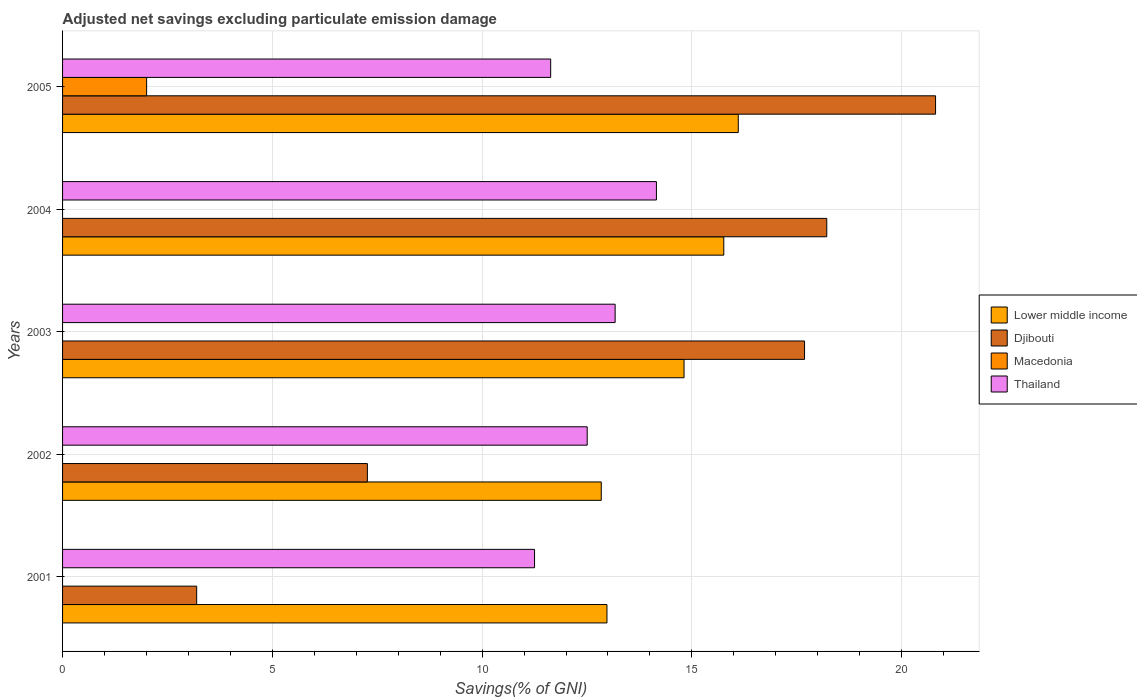How many groups of bars are there?
Keep it short and to the point. 5. Are the number of bars per tick equal to the number of legend labels?
Give a very brief answer. No. Are the number of bars on each tick of the Y-axis equal?
Your answer should be very brief. No. How many bars are there on the 5th tick from the top?
Offer a terse response. 3. How many bars are there on the 4th tick from the bottom?
Keep it short and to the point. 3. What is the adjusted net savings in Macedonia in 2003?
Your answer should be compact. 0. Across all years, what is the maximum adjusted net savings in Thailand?
Make the answer very short. 14.16. Across all years, what is the minimum adjusted net savings in Djibouti?
Provide a short and direct response. 3.2. What is the total adjusted net savings in Thailand in the graph?
Your answer should be very brief. 62.72. What is the difference between the adjusted net savings in Thailand in 2004 and that in 2005?
Offer a terse response. 2.52. What is the difference between the adjusted net savings in Lower middle income in 2005 and the adjusted net savings in Thailand in 2002?
Keep it short and to the point. 3.6. What is the average adjusted net savings in Thailand per year?
Offer a terse response. 12.54. In the year 2002, what is the difference between the adjusted net savings in Thailand and adjusted net savings in Lower middle income?
Your answer should be very brief. -0.33. In how many years, is the adjusted net savings in Djibouti greater than 1 %?
Your response must be concise. 5. What is the ratio of the adjusted net savings in Thailand in 2001 to that in 2004?
Give a very brief answer. 0.79. What is the difference between the highest and the second highest adjusted net savings in Djibouti?
Offer a very short reply. 2.59. What is the difference between the highest and the lowest adjusted net savings in Macedonia?
Your answer should be compact. 2. In how many years, is the adjusted net savings in Thailand greater than the average adjusted net savings in Thailand taken over all years?
Ensure brevity in your answer.  2. Is it the case that in every year, the sum of the adjusted net savings in Macedonia and adjusted net savings in Djibouti is greater than the adjusted net savings in Lower middle income?
Ensure brevity in your answer.  No. How many bars are there?
Provide a succinct answer. 16. How many years are there in the graph?
Give a very brief answer. 5. What is the difference between two consecutive major ticks on the X-axis?
Offer a very short reply. 5. Does the graph contain grids?
Your answer should be very brief. Yes. Where does the legend appear in the graph?
Offer a very short reply. Center right. What is the title of the graph?
Your response must be concise. Adjusted net savings excluding particulate emission damage. Does "China" appear as one of the legend labels in the graph?
Provide a short and direct response. No. What is the label or title of the X-axis?
Your answer should be very brief. Savings(% of GNI). What is the Savings(% of GNI) in Lower middle income in 2001?
Your answer should be very brief. 12.98. What is the Savings(% of GNI) of Djibouti in 2001?
Ensure brevity in your answer.  3.2. What is the Savings(% of GNI) of Thailand in 2001?
Make the answer very short. 11.25. What is the Savings(% of GNI) of Lower middle income in 2002?
Provide a short and direct response. 12.84. What is the Savings(% of GNI) in Djibouti in 2002?
Your answer should be compact. 7.27. What is the Savings(% of GNI) of Macedonia in 2002?
Offer a terse response. 0. What is the Savings(% of GNI) of Thailand in 2002?
Your answer should be compact. 12.51. What is the Savings(% of GNI) in Lower middle income in 2003?
Keep it short and to the point. 14.81. What is the Savings(% of GNI) of Djibouti in 2003?
Offer a very short reply. 17.69. What is the Savings(% of GNI) of Macedonia in 2003?
Your answer should be compact. 0. What is the Savings(% of GNI) of Thailand in 2003?
Provide a succinct answer. 13.17. What is the Savings(% of GNI) in Lower middle income in 2004?
Provide a succinct answer. 15.76. What is the Savings(% of GNI) in Djibouti in 2004?
Your response must be concise. 18.22. What is the Savings(% of GNI) of Thailand in 2004?
Offer a very short reply. 14.16. What is the Savings(% of GNI) of Lower middle income in 2005?
Give a very brief answer. 16.11. What is the Savings(% of GNI) in Djibouti in 2005?
Your answer should be compact. 20.81. What is the Savings(% of GNI) in Macedonia in 2005?
Provide a short and direct response. 2. What is the Savings(% of GNI) of Thailand in 2005?
Make the answer very short. 11.63. Across all years, what is the maximum Savings(% of GNI) of Lower middle income?
Make the answer very short. 16.11. Across all years, what is the maximum Savings(% of GNI) of Djibouti?
Your answer should be very brief. 20.81. Across all years, what is the maximum Savings(% of GNI) in Macedonia?
Give a very brief answer. 2. Across all years, what is the maximum Savings(% of GNI) of Thailand?
Your answer should be compact. 14.16. Across all years, what is the minimum Savings(% of GNI) of Lower middle income?
Your answer should be very brief. 12.84. Across all years, what is the minimum Savings(% of GNI) in Djibouti?
Provide a succinct answer. 3.2. Across all years, what is the minimum Savings(% of GNI) in Thailand?
Ensure brevity in your answer.  11.25. What is the total Savings(% of GNI) in Lower middle income in the graph?
Give a very brief answer. 72.5. What is the total Savings(% of GNI) in Djibouti in the graph?
Your answer should be compact. 67.17. What is the total Savings(% of GNI) of Macedonia in the graph?
Offer a terse response. 2. What is the total Savings(% of GNI) in Thailand in the graph?
Provide a short and direct response. 62.72. What is the difference between the Savings(% of GNI) in Lower middle income in 2001 and that in 2002?
Provide a succinct answer. 0.14. What is the difference between the Savings(% of GNI) of Djibouti in 2001 and that in 2002?
Keep it short and to the point. -4.07. What is the difference between the Savings(% of GNI) of Thailand in 2001 and that in 2002?
Ensure brevity in your answer.  -1.26. What is the difference between the Savings(% of GNI) in Lower middle income in 2001 and that in 2003?
Make the answer very short. -1.84. What is the difference between the Savings(% of GNI) of Djibouti in 2001 and that in 2003?
Make the answer very short. -14.49. What is the difference between the Savings(% of GNI) of Thailand in 2001 and that in 2003?
Provide a short and direct response. -1.92. What is the difference between the Savings(% of GNI) in Lower middle income in 2001 and that in 2004?
Provide a succinct answer. -2.78. What is the difference between the Savings(% of GNI) in Djibouti in 2001 and that in 2004?
Provide a succinct answer. -15.02. What is the difference between the Savings(% of GNI) in Thailand in 2001 and that in 2004?
Provide a succinct answer. -2.9. What is the difference between the Savings(% of GNI) of Lower middle income in 2001 and that in 2005?
Your response must be concise. -3.13. What is the difference between the Savings(% of GNI) in Djibouti in 2001 and that in 2005?
Ensure brevity in your answer.  -17.61. What is the difference between the Savings(% of GNI) in Thailand in 2001 and that in 2005?
Ensure brevity in your answer.  -0.38. What is the difference between the Savings(% of GNI) of Lower middle income in 2002 and that in 2003?
Offer a terse response. -1.97. What is the difference between the Savings(% of GNI) of Djibouti in 2002 and that in 2003?
Provide a succinct answer. -10.42. What is the difference between the Savings(% of GNI) of Thailand in 2002 and that in 2003?
Offer a terse response. -0.67. What is the difference between the Savings(% of GNI) of Lower middle income in 2002 and that in 2004?
Offer a very short reply. -2.92. What is the difference between the Savings(% of GNI) of Djibouti in 2002 and that in 2004?
Make the answer very short. -10.95. What is the difference between the Savings(% of GNI) of Thailand in 2002 and that in 2004?
Your answer should be compact. -1.65. What is the difference between the Savings(% of GNI) in Lower middle income in 2002 and that in 2005?
Give a very brief answer. -3.27. What is the difference between the Savings(% of GNI) of Djibouti in 2002 and that in 2005?
Give a very brief answer. -13.54. What is the difference between the Savings(% of GNI) in Thailand in 2002 and that in 2005?
Your answer should be very brief. 0.87. What is the difference between the Savings(% of GNI) of Lower middle income in 2003 and that in 2004?
Your response must be concise. -0.95. What is the difference between the Savings(% of GNI) of Djibouti in 2003 and that in 2004?
Give a very brief answer. -0.53. What is the difference between the Savings(% of GNI) of Thailand in 2003 and that in 2004?
Offer a terse response. -0.98. What is the difference between the Savings(% of GNI) in Lower middle income in 2003 and that in 2005?
Make the answer very short. -1.29. What is the difference between the Savings(% of GNI) in Djibouti in 2003 and that in 2005?
Keep it short and to the point. -3.12. What is the difference between the Savings(% of GNI) in Thailand in 2003 and that in 2005?
Provide a short and direct response. 1.54. What is the difference between the Savings(% of GNI) in Lower middle income in 2004 and that in 2005?
Your answer should be very brief. -0.35. What is the difference between the Savings(% of GNI) in Djibouti in 2004 and that in 2005?
Give a very brief answer. -2.59. What is the difference between the Savings(% of GNI) of Thailand in 2004 and that in 2005?
Make the answer very short. 2.52. What is the difference between the Savings(% of GNI) of Lower middle income in 2001 and the Savings(% of GNI) of Djibouti in 2002?
Your answer should be compact. 5.71. What is the difference between the Savings(% of GNI) of Lower middle income in 2001 and the Savings(% of GNI) of Thailand in 2002?
Your answer should be very brief. 0.47. What is the difference between the Savings(% of GNI) in Djibouti in 2001 and the Savings(% of GNI) in Thailand in 2002?
Give a very brief answer. -9.31. What is the difference between the Savings(% of GNI) in Lower middle income in 2001 and the Savings(% of GNI) in Djibouti in 2003?
Your response must be concise. -4.71. What is the difference between the Savings(% of GNI) of Lower middle income in 2001 and the Savings(% of GNI) of Thailand in 2003?
Make the answer very short. -0.2. What is the difference between the Savings(% of GNI) in Djibouti in 2001 and the Savings(% of GNI) in Thailand in 2003?
Your answer should be compact. -9.97. What is the difference between the Savings(% of GNI) of Lower middle income in 2001 and the Savings(% of GNI) of Djibouti in 2004?
Keep it short and to the point. -5.24. What is the difference between the Savings(% of GNI) in Lower middle income in 2001 and the Savings(% of GNI) in Thailand in 2004?
Offer a terse response. -1.18. What is the difference between the Savings(% of GNI) of Djibouti in 2001 and the Savings(% of GNI) of Thailand in 2004?
Make the answer very short. -10.96. What is the difference between the Savings(% of GNI) in Lower middle income in 2001 and the Savings(% of GNI) in Djibouti in 2005?
Give a very brief answer. -7.83. What is the difference between the Savings(% of GNI) of Lower middle income in 2001 and the Savings(% of GNI) of Macedonia in 2005?
Your answer should be very brief. 10.97. What is the difference between the Savings(% of GNI) of Lower middle income in 2001 and the Savings(% of GNI) of Thailand in 2005?
Make the answer very short. 1.34. What is the difference between the Savings(% of GNI) in Djibouti in 2001 and the Savings(% of GNI) in Macedonia in 2005?
Your answer should be compact. 1.19. What is the difference between the Savings(% of GNI) in Djibouti in 2001 and the Savings(% of GNI) in Thailand in 2005?
Keep it short and to the point. -8.44. What is the difference between the Savings(% of GNI) in Lower middle income in 2002 and the Savings(% of GNI) in Djibouti in 2003?
Your response must be concise. -4.85. What is the difference between the Savings(% of GNI) of Lower middle income in 2002 and the Savings(% of GNI) of Thailand in 2003?
Give a very brief answer. -0.33. What is the difference between the Savings(% of GNI) in Djibouti in 2002 and the Savings(% of GNI) in Thailand in 2003?
Ensure brevity in your answer.  -5.91. What is the difference between the Savings(% of GNI) in Lower middle income in 2002 and the Savings(% of GNI) in Djibouti in 2004?
Your response must be concise. -5.38. What is the difference between the Savings(% of GNI) in Lower middle income in 2002 and the Savings(% of GNI) in Thailand in 2004?
Keep it short and to the point. -1.31. What is the difference between the Savings(% of GNI) in Djibouti in 2002 and the Savings(% of GNI) in Thailand in 2004?
Your answer should be very brief. -6.89. What is the difference between the Savings(% of GNI) of Lower middle income in 2002 and the Savings(% of GNI) of Djibouti in 2005?
Give a very brief answer. -7.97. What is the difference between the Savings(% of GNI) in Lower middle income in 2002 and the Savings(% of GNI) in Macedonia in 2005?
Ensure brevity in your answer.  10.84. What is the difference between the Savings(% of GNI) of Lower middle income in 2002 and the Savings(% of GNI) of Thailand in 2005?
Your answer should be very brief. 1.21. What is the difference between the Savings(% of GNI) of Djibouti in 2002 and the Savings(% of GNI) of Macedonia in 2005?
Give a very brief answer. 5.26. What is the difference between the Savings(% of GNI) in Djibouti in 2002 and the Savings(% of GNI) in Thailand in 2005?
Offer a terse response. -4.37. What is the difference between the Savings(% of GNI) of Lower middle income in 2003 and the Savings(% of GNI) of Djibouti in 2004?
Your answer should be very brief. -3.4. What is the difference between the Savings(% of GNI) of Lower middle income in 2003 and the Savings(% of GNI) of Thailand in 2004?
Your answer should be very brief. 0.66. What is the difference between the Savings(% of GNI) of Djibouti in 2003 and the Savings(% of GNI) of Thailand in 2004?
Provide a succinct answer. 3.53. What is the difference between the Savings(% of GNI) of Lower middle income in 2003 and the Savings(% of GNI) of Djibouti in 2005?
Ensure brevity in your answer.  -6. What is the difference between the Savings(% of GNI) in Lower middle income in 2003 and the Savings(% of GNI) in Macedonia in 2005?
Offer a very short reply. 12.81. What is the difference between the Savings(% of GNI) of Lower middle income in 2003 and the Savings(% of GNI) of Thailand in 2005?
Your answer should be compact. 3.18. What is the difference between the Savings(% of GNI) in Djibouti in 2003 and the Savings(% of GNI) in Macedonia in 2005?
Ensure brevity in your answer.  15.68. What is the difference between the Savings(% of GNI) of Djibouti in 2003 and the Savings(% of GNI) of Thailand in 2005?
Your answer should be very brief. 6.05. What is the difference between the Savings(% of GNI) in Lower middle income in 2004 and the Savings(% of GNI) in Djibouti in 2005?
Give a very brief answer. -5.05. What is the difference between the Savings(% of GNI) in Lower middle income in 2004 and the Savings(% of GNI) in Macedonia in 2005?
Give a very brief answer. 13.76. What is the difference between the Savings(% of GNI) in Lower middle income in 2004 and the Savings(% of GNI) in Thailand in 2005?
Give a very brief answer. 4.13. What is the difference between the Savings(% of GNI) in Djibouti in 2004 and the Savings(% of GNI) in Macedonia in 2005?
Your response must be concise. 16.21. What is the difference between the Savings(% of GNI) of Djibouti in 2004 and the Savings(% of GNI) of Thailand in 2005?
Provide a short and direct response. 6.58. What is the average Savings(% of GNI) of Lower middle income per year?
Offer a terse response. 14.5. What is the average Savings(% of GNI) of Djibouti per year?
Make the answer very short. 13.43. What is the average Savings(% of GNI) in Macedonia per year?
Make the answer very short. 0.4. What is the average Savings(% of GNI) in Thailand per year?
Ensure brevity in your answer.  12.54. In the year 2001, what is the difference between the Savings(% of GNI) of Lower middle income and Savings(% of GNI) of Djibouti?
Offer a terse response. 9.78. In the year 2001, what is the difference between the Savings(% of GNI) of Lower middle income and Savings(% of GNI) of Thailand?
Make the answer very short. 1.73. In the year 2001, what is the difference between the Savings(% of GNI) of Djibouti and Savings(% of GNI) of Thailand?
Provide a succinct answer. -8.05. In the year 2002, what is the difference between the Savings(% of GNI) of Lower middle income and Savings(% of GNI) of Djibouti?
Ensure brevity in your answer.  5.57. In the year 2002, what is the difference between the Savings(% of GNI) of Lower middle income and Savings(% of GNI) of Thailand?
Provide a succinct answer. 0.33. In the year 2002, what is the difference between the Savings(% of GNI) of Djibouti and Savings(% of GNI) of Thailand?
Offer a very short reply. -5.24. In the year 2003, what is the difference between the Savings(% of GNI) of Lower middle income and Savings(% of GNI) of Djibouti?
Give a very brief answer. -2.87. In the year 2003, what is the difference between the Savings(% of GNI) of Lower middle income and Savings(% of GNI) of Thailand?
Offer a very short reply. 1.64. In the year 2003, what is the difference between the Savings(% of GNI) of Djibouti and Savings(% of GNI) of Thailand?
Provide a succinct answer. 4.51. In the year 2004, what is the difference between the Savings(% of GNI) in Lower middle income and Savings(% of GNI) in Djibouti?
Provide a short and direct response. -2.45. In the year 2004, what is the difference between the Savings(% of GNI) of Lower middle income and Savings(% of GNI) of Thailand?
Your answer should be compact. 1.61. In the year 2004, what is the difference between the Savings(% of GNI) in Djibouti and Savings(% of GNI) in Thailand?
Your response must be concise. 4.06. In the year 2005, what is the difference between the Savings(% of GNI) of Lower middle income and Savings(% of GNI) of Djibouti?
Offer a terse response. -4.7. In the year 2005, what is the difference between the Savings(% of GNI) of Lower middle income and Savings(% of GNI) of Macedonia?
Provide a succinct answer. 14.1. In the year 2005, what is the difference between the Savings(% of GNI) in Lower middle income and Savings(% of GNI) in Thailand?
Give a very brief answer. 4.47. In the year 2005, what is the difference between the Savings(% of GNI) in Djibouti and Savings(% of GNI) in Macedonia?
Offer a terse response. 18.8. In the year 2005, what is the difference between the Savings(% of GNI) in Djibouti and Savings(% of GNI) in Thailand?
Keep it short and to the point. 9.17. In the year 2005, what is the difference between the Savings(% of GNI) in Macedonia and Savings(% of GNI) in Thailand?
Your response must be concise. -9.63. What is the ratio of the Savings(% of GNI) of Lower middle income in 2001 to that in 2002?
Your answer should be compact. 1.01. What is the ratio of the Savings(% of GNI) of Djibouti in 2001 to that in 2002?
Give a very brief answer. 0.44. What is the ratio of the Savings(% of GNI) in Thailand in 2001 to that in 2002?
Give a very brief answer. 0.9. What is the ratio of the Savings(% of GNI) of Lower middle income in 2001 to that in 2003?
Your answer should be compact. 0.88. What is the ratio of the Savings(% of GNI) of Djibouti in 2001 to that in 2003?
Ensure brevity in your answer.  0.18. What is the ratio of the Savings(% of GNI) of Thailand in 2001 to that in 2003?
Your answer should be compact. 0.85. What is the ratio of the Savings(% of GNI) of Lower middle income in 2001 to that in 2004?
Offer a very short reply. 0.82. What is the ratio of the Savings(% of GNI) of Djibouti in 2001 to that in 2004?
Provide a succinct answer. 0.18. What is the ratio of the Savings(% of GNI) of Thailand in 2001 to that in 2004?
Keep it short and to the point. 0.79. What is the ratio of the Savings(% of GNI) of Lower middle income in 2001 to that in 2005?
Make the answer very short. 0.81. What is the ratio of the Savings(% of GNI) of Djibouti in 2001 to that in 2005?
Provide a short and direct response. 0.15. What is the ratio of the Savings(% of GNI) of Thailand in 2001 to that in 2005?
Your answer should be compact. 0.97. What is the ratio of the Savings(% of GNI) in Lower middle income in 2002 to that in 2003?
Offer a terse response. 0.87. What is the ratio of the Savings(% of GNI) in Djibouti in 2002 to that in 2003?
Give a very brief answer. 0.41. What is the ratio of the Savings(% of GNI) in Thailand in 2002 to that in 2003?
Provide a succinct answer. 0.95. What is the ratio of the Savings(% of GNI) of Lower middle income in 2002 to that in 2004?
Provide a short and direct response. 0.81. What is the ratio of the Savings(% of GNI) in Djibouti in 2002 to that in 2004?
Your response must be concise. 0.4. What is the ratio of the Savings(% of GNI) of Thailand in 2002 to that in 2004?
Keep it short and to the point. 0.88. What is the ratio of the Savings(% of GNI) in Lower middle income in 2002 to that in 2005?
Your answer should be compact. 0.8. What is the ratio of the Savings(% of GNI) in Djibouti in 2002 to that in 2005?
Keep it short and to the point. 0.35. What is the ratio of the Savings(% of GNI) in Thailand in 2002 to that in 2005?
Keep it short and to the point. 1.07. What is the ratio of the Savings(% of GNI) of Lower middle income in 2003 to that in 2004?
Ensure brevity in your answer.  0.94. What is the ratio of the Savings(% of GNI) in Djibouti in 2003 to that in 2004?
Provide a succinct answer. 0.97. What is the ratio of the Savings(% of GNI) of Thailand in 2003 to that in 2004?
Offer a terse response. 0.93. What is the ratio of the Savings(% of GNI) of Lower middle income in 2003 to that in 2005?
Provide a short and direct response. 0.92. What is the ratio of the Savings(% of GNI) of Djibouti in 2003 to that in 2005?
Your response must be concise. 0.85. What is the ratio of the Savings(% of GNI) in Thailand in 2003 to that in 2005?
Give a very brief answer. 1.13. What is the ratio of the Savings(% of GNI) in Lower middle income in 2004 to that in 2005?
Keep it short and to the point. 0.98. What is the ratio of the Savings(% of GNI) of Djibouti in 2004 to that in 2005?
Your answer should be very brief. 0.88. What is the ratio of the Savings(% of GNI) of Thailand in 2004 to that in 2005?
Offer a very short reply. 1.22. What is the difference between the highest and the second highest Savings(% of GNI) of Lower middle income?
Provide a succinct answer. 0.35. What is the difference between the highest and the second highest Savings(% of GNI) of Djibouti?
Offer a terse response. 2.59. What is the difference between the highest and the second highest Savings(% of GNI) in Thailand?
Your answer should be very brief. 0.98. What is the difference between the highest and the lowest Savings(% of GNI) of Lower middle income?
Offer a very short reply. 3.27. What is the difference between the highest and the lowest Savings(% of GNI) in Djibouti?
Make the answer very short. 17.61. What is the difference between the highest and the lowest Savings(% of GNI) in Macedonia?
Offer a terse response. 2. What is the difference between the highest and the lowest Savings(% of GNI) in Thailand?
Give a very brief answer. 2.9. 